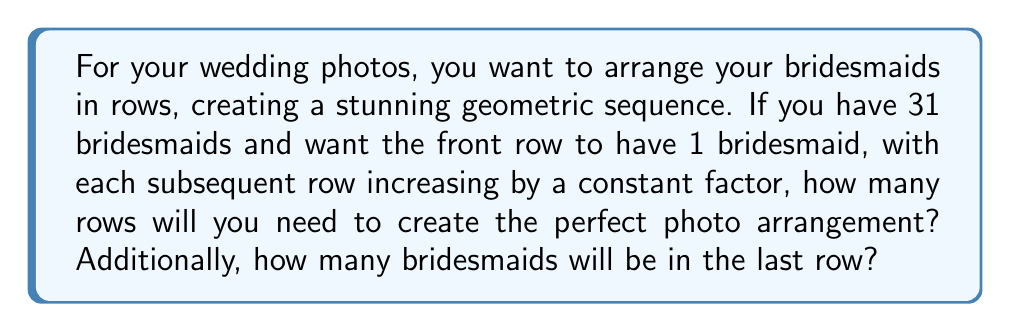Can you solve this math problem? Let's approach this step-by-step using the properties of geometric sequences:

1) In a geometric sequence, each term is a constant multiple of the previous term. Let's call this constant $r$.

2) The number of bridesmaids in each row forms a geometric sequence: $1, r, r^2, r^3, ...$

3) The sum of a geometric sequence is given by the formula:
   $$S_n = \frac{a(1-r^n)}{1-r}$$
   where $a$ is the first term, $r$ is the common ratio, and $n$ is the number of terms.

4) In this case, we know:
   $a = 1$ (first row has 1 bridesmaid)
   $S_n = 31$ (total number of bridesmaids)

5) We need to find $r$ and $n$. Let's try some values for $r$:
   If $r = 2$, then $1 + 2 + 4 + 8 + 16 = 31$

6) This works perfectly! We have 5 terms, so $n = 5$.

7) To verify:
   $$31 = \frac{1(1-2^5)}{1-2} = \frac{1(1-32)}{-1} = 31$$

8) The number of rows is therefore 5.

9) The last row will have $2^4 = 16$ bridesmaids, as it's the 5th term in the sequence $1, 2, 4, 8, 16$.
Answer: 5 rows; 16 bridesmaids in the last row 